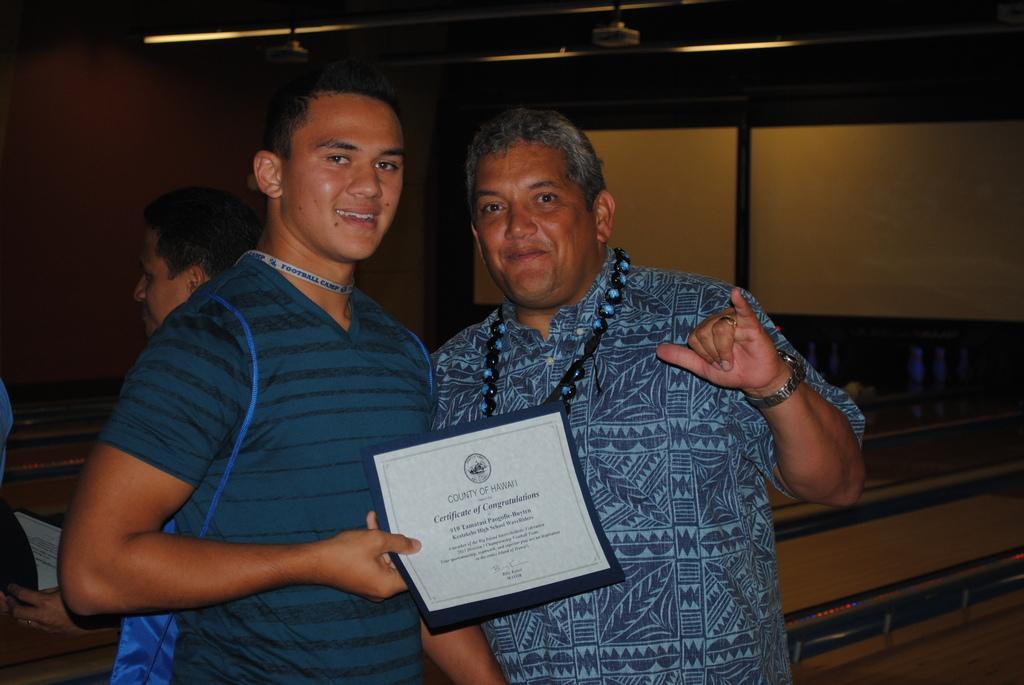Could you give a brief overview of what you see in this image? In this picture we can see a group of people standing and two people holding the certificate papers. Behind the people, they look like benches, projector screen and the wall. At the top there are projectors. 